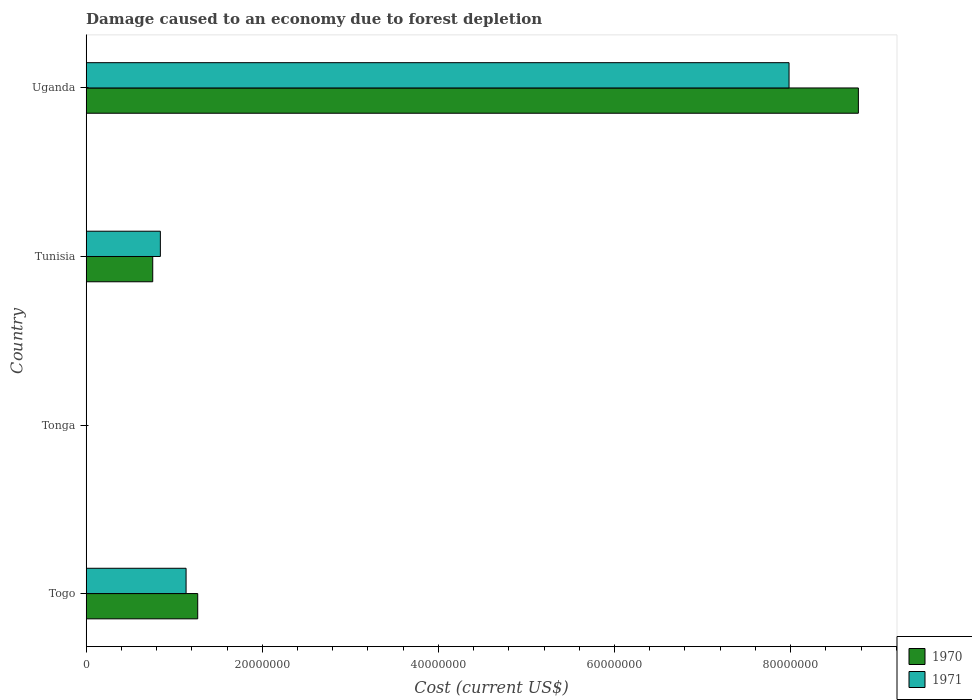Are the number of bars per tick equal to the number of legend labels?
Your answer should be compact. Yes. Are the number of bars on each tick of the Y-axis equal?
Provide a succinct answer. Yes. How many bars are there on the 3rd tick from the bottom?
Your answer should be compact. 2. What is the label of the 1st group of bars from the top?
Provide a succinct answer. Uganda. In how many cases, is the number of bars for a given country not equal to the number of legend labels?
Offer a terse response. 0. What is the cost of damage caused due to forest depletion in 1971 in Tonga?
Provide a short and direct response. 4376.43. Across all countries, what is the maximum cost of damage caused due to forest depletion in 1971?
Offer a terse response. 7.98e+07. Across all countries, what is the minimum cost of damage caused due to forest depletion in 1971?
Offer a very short reply. 4376.43. In which country was the cost of damage caused due to forest depletion in 1971 maximum?
Ensure brevity in your answer.  Uganda. In which country was the cost of damage caused due to forest depletion in 1970 minimum?
Ensure brevity in your answer.  Tonga. What is the total cost of damage caused due to forest depletion in 1970 in the graph?
Keep it short and to the point. 1.08e+08. What is the difference between the cost of damage caused due to forest depletion in 1971 in Togo and that in Tonga?
Keep it short and to the point. 1.13e+07. What is the difference between the cost of damage caused due to forest depletion in 1971 in Uganda and the cost of damage caused due to forest depletion in 1970 in Tunisia?
Give a very brief answer. 7.23e+07. What is the average cost of damage caused due to forest depletion in 1970 per country?
Keep it short and to the point. 2.70e+07. What is the difference between the cost of damage caused due to forest depletion in 1970 and cost of damage caused due to forest depletion in 1971 in Tunisia?
Your answer should be very brief. -8.66e+05. What is the ratio of the cost of damage caused due to forest depletion in 1971 in Tunisia to that in Uganda?
Provide a succinct answer. 0.11. What is the difference between the highest and the second highest cost of damage caused due to forest depletion in 1970?
Provide a short and direct response. 7.50e+07. What is the difference between the highest and the lowest cost of damage caused due to forest depletion in 1971?
Keep it short and to the point. 7.98e+07. What does the 2nd bar from the top in Togo represents?
Ensure brevity in your answer.  1970. Are all the bars in the graph horizontal?
Offer a terse response. Yes. Are the values on the major ticks of X-axis written in scientific E-notation?
Make the answer very short. No. Does the graph contain grids?
Offer a very short reply. No. Where does the legend appear in the graph?
Your answer should be compact. Bottom right. How many legend labels are there?
Offer a terse response. 2. How are the legend labels stacked?
Your answer should be very brief. Vertical. What is the title of the graph?
Make the answer very short. Damage caused to an economy due to forest depletion. What is the label or title of the X-axis?
Your answer should be compact. Cost (current US$). What is the label or title of the Y-axis?
Your answer should be very brief. Country. What is the Cost (current US$) in 1970 in Togo?
Provide a succinct answer. 1.27e+07. What is the Cost (current US$) in 1971 in Togo?
Provide a short and direct response. 1.13e+07. What is the Cost (current US$) in 1970 in Tonga?
Your answer should be compact. 4901.94. What is the Cost (current US$) of 1971 in Tonga?
Your answer should be compact. 4376.43. What is the Cost (current US$) in 1970 in Tunisia?
Offer a terse response. 7.56e+06. What is the Cost (current US$) in 1971 in Tunisia?
Ensure brevity in your answer.  8.42e+06. What is the Cost (current US$) in 1970 in Uganda?
Your answer should be compact. 8.77e+07. What is the Cost (current US$) of 1971 in Uganda?
Offer a very short reply. 7.98e+07. Across all countries, what is the maximum Cost (current US$) of 1970?
Make the answer very short. 8.77e+07. Across all countries, what is the maximum Cost (current US$) in 1971?
Your answer should be very brief. 7.98e+07. Across all countries, what is the minimum Cost (current US$) of 1970?
Keep it short and to the point. 4901.94. Across all countries, what is the minimum Cost (current US$) in 1971?
Your answer should be compact. 4376.43. What is the total Cost (current US$) in 1970 in the graph?
Your response must be concise. 1.08e+08. What is the total Cost (current US$) of 1971 in the graph?
Make the answer very short. 9.96e+07. What is the difference between the Cost (current US$) of 1970 in Togo and that in Tonga?
Ensure brevity in your answer.  1.27e+07. What is the difference between the Cost (current US$) of 1971 in Togo and that in Tonga?
Provide a succinct answer. 1.13e+07. What is the difference between the Cost (current US$) in 1970 in Togo and that in Tunisia?
Provide a short and direct response. 5.11e+06. What is the difference between the Cost (current US$) of 1971 in Togo and that in Tunisia?
Offer a terse response. 2.92e+06. What is the difference between the Cost (current US$) in 1970 in Togo and that in Uganda?
Offer a very short reply. -7.50e+07. What is the difference between the Cost (current US$) of 1971 in Togo and that in Uganda?
Provide a succinct answer. -6.85e+07. What is the difference between the Cost (current US$) in 1970 in Tonga and that in Tunisia?
Provide a short and direct response. -7.55e+06. What is the difference between the Cost (current US$) in 1971 in Tonga and that in Tunisia?
Keep it short and to the point. -8.42e+06. What is the difference between the Cost (current US$) in 1970 in Tonga and that in Uganda?
Your answer should be compact. -8.77e+07. What is the difference between the Cost (current US$) in 1971 in Tonga and that in Uganda?
Offer a terse response. -7.98e+07. What is the difference between the Cost (current US$) in 1970 in Tunisia and that in Uganda?
Provide a short and direct response. -8.01e+07. What is the difference between the Cost (current US$) in 1971 in Tunisia and that in Uganda?
Provide a short and direct response. -7.14e+07. What is the difference between the Cost (current US$) of 1970 in Togo and the Cost (current US$) of 1971 in Tonga?
Your answer should be compact. 1.27e+07. What is the difference between the Cost (current US$) of 1970 in Togo and the Cost (current US$) of 1971 in Tunisia?
Your answer should be very brief. 4.24e+06. What is the difference between the Cost (current US$) in 1970 in Togo and the Cost (current US$) in 1971 in Uganda?
Your answer should be compact. -6.72e+07. What is the difference between the Cost (current US$) of 1970 in Tonga and the Cost (current US$) of 1971 in Tunisia?
Your answer should be very brief. -8.42e+06. What is the difference between the Cost (current US$) in 1970 in Tonga and the Cost (current US$) in 1971 in Uganda?
Your answer should be very brief. -7.98e+07. What is the difference between the Cost (current US$) of 1970 in Tunisia and the Cost (current US$) of 1971 in Uganda?
Ensure brevity in your answer.  -7.23e+07. What is the average Cost (current US$) of 1970 per country?
Offer a terse response. 2.70e+07. What is the average Cost (current US$) of 1971 per country?
Offer a very short reply. 2.49e+07. What is the difference between the Cost (current US$) of 1970 and Cost (current US$) of 1971 in Togo?
Offer a very short reply. 1.32e+06. What is the difference between the Cost (current US$) of 1970 and Cost (current US$) of 1971 in Tonga?
Your response must be concise. 525.51. What is the difference between the Cost (current US$) in 1970 and Cost (current US$) in 1971 in Tunisia?
Provide a succinct answer. -8.66e+05. What is the difference between the Cost (current US$) of 1970 and Cost (current US$) of 1971 in Uganda?
Provide a short and direct response. 7.87e+06. What is the ratio of the Cost (current US$) of 1970 in Togo to that in Tonga?
Your response must be concise. 2583.92. What is the ratio of the Cost (current US$) in 1971 in Togo to that in Tonga?
Keep it short and to the point. 2592.16. What is the ratio of the Cost (current US$) of 1970 in Togo to that in Tunisia?
Your answer should be very brief. 1.68. What is the ratio of the Cost (current US$) of 1971 in Togo to that in Tunisia?
Offer a terse response. 1.35. What is the ratio of the Cost (current US$) of 1970 in Togo to that in Uganda?
Provide a succinct answer. 0.14. What is the ratio of the Cost (current US$) of 1971 in Togo to that in Uganda?
Give a very brief answer. 0.14. What is the ratio of the Cost (current US$) of 1970 in Tonga to that in Tunisia?
Provide a short and direct response. 0. What is the ratio of the Cost (current US$) of 1970 in Tonga to that in Uganda?
Ensure brevity in your answer.  0. What is the ratio of the Cost (current US$) in 1970 in Tunisia to that in Uganda?
Your answer should be very brief. 0.09. What is the ratio of the Cost (current US$) of 1971 in Tunisia to that in Uganda?
Provide a short and direct response. 0.11. What is the difference between the highest and the second highest Cost (current US$) of 1970?
Provide a short and direct response. 7.50e+07. What is the difference between the highest and the second highest Cost (current US$) in 1971?
Offer a terse response. 6.85e+07. What is the difference between the highest and the lowest Cost (current US$) in 1970?
Offer a very short reply. 8.77e+07. What is the difference between the highest and the lowest Cost (current US$) in 1971?
Make the answer very short. 7.98e+07. 